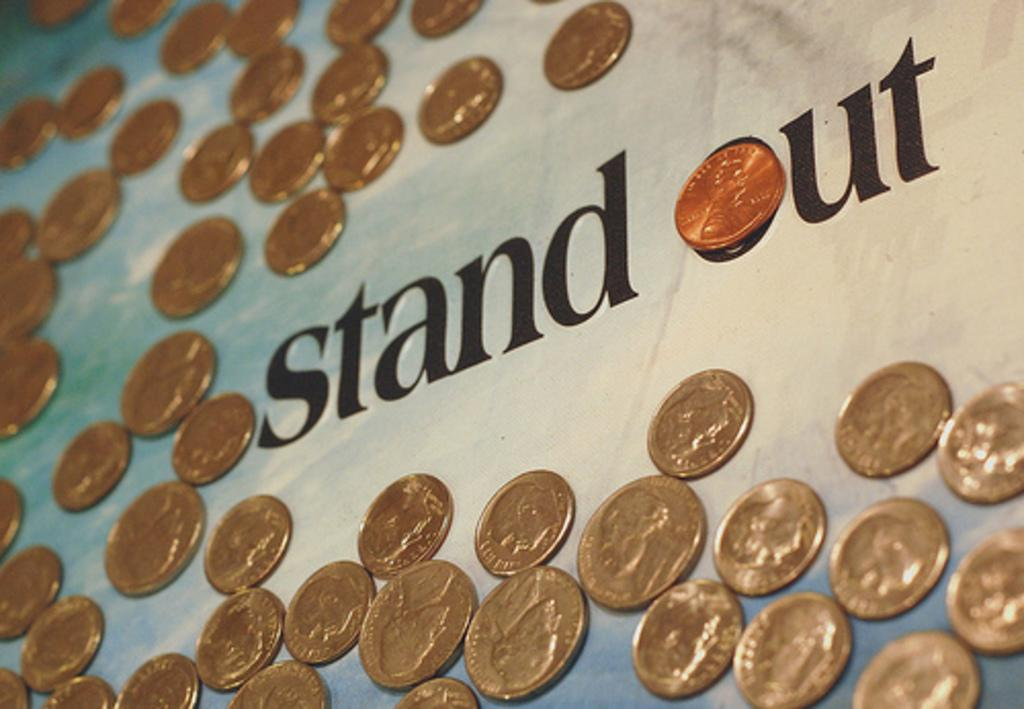What objects are on the table in the image? There are coins on a table in the image. What else can be seen on the table besides the coins? There is text present on the table in the image. Can you see a tooth floating in the lake in the image? There is no tooth or lake present in the image; it only features coins and text on a table. 